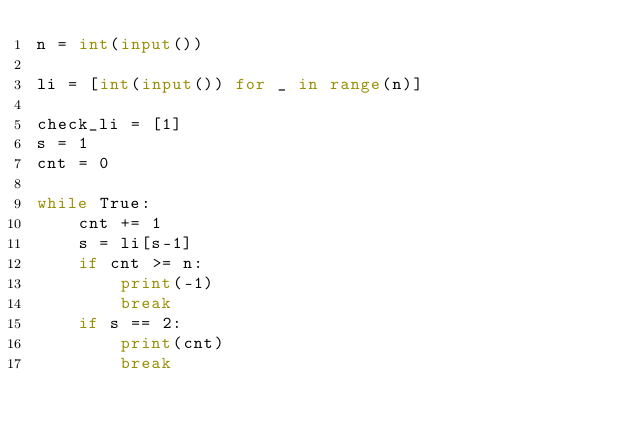<code> <loc_0><loc_0><loc_500><loc_500><_Python_>n = int(input())

li = [int(input()) for _ in range(n)]

check_li = [1]
s = 1
cnt = 0

while True:
    cnt += 1
    s = li[s-1]
    if cnt >= n:
        print(-1)
        break
    if s == 2:
        print(cnt)
        break
    </code> 